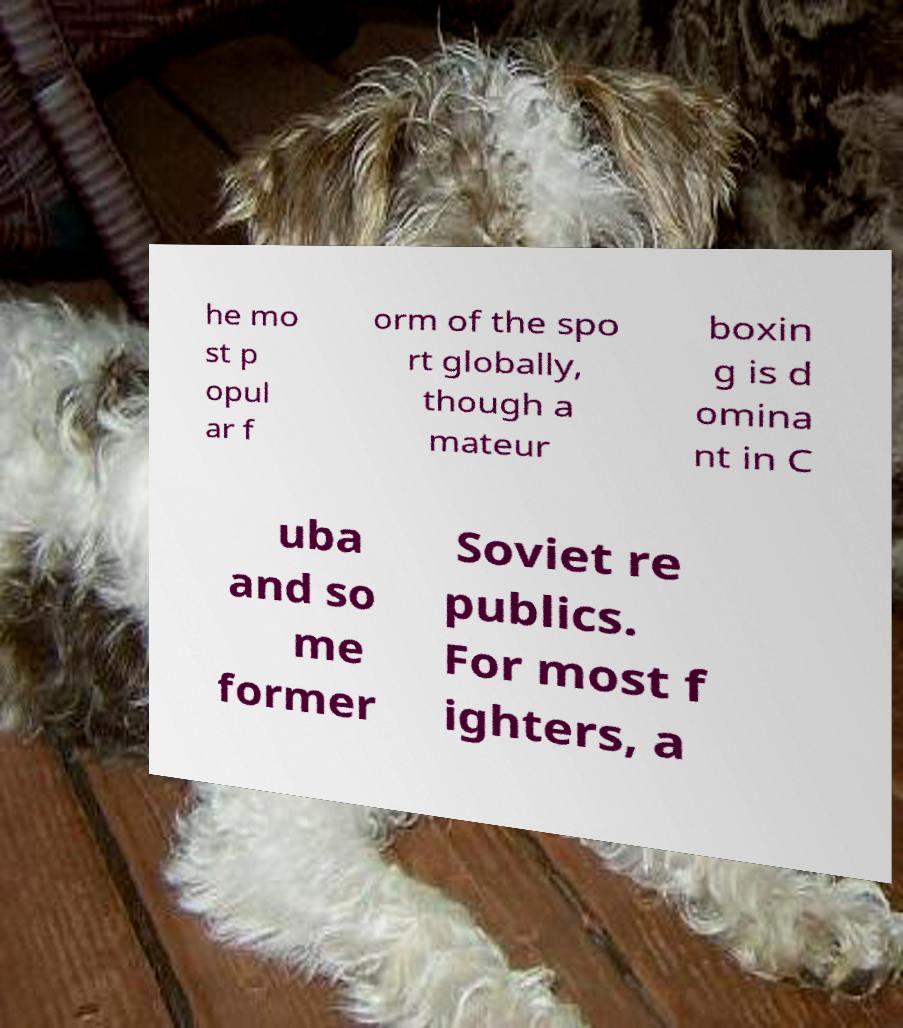There's text embedded in this image that I need extracted. Can you transcribe it verbatim? he mo st p opul ar f orm of the spo rt globally, though a mateur boxin g is d omina nt in C uba and so me former Soviet re publics. For most f ighters, a 